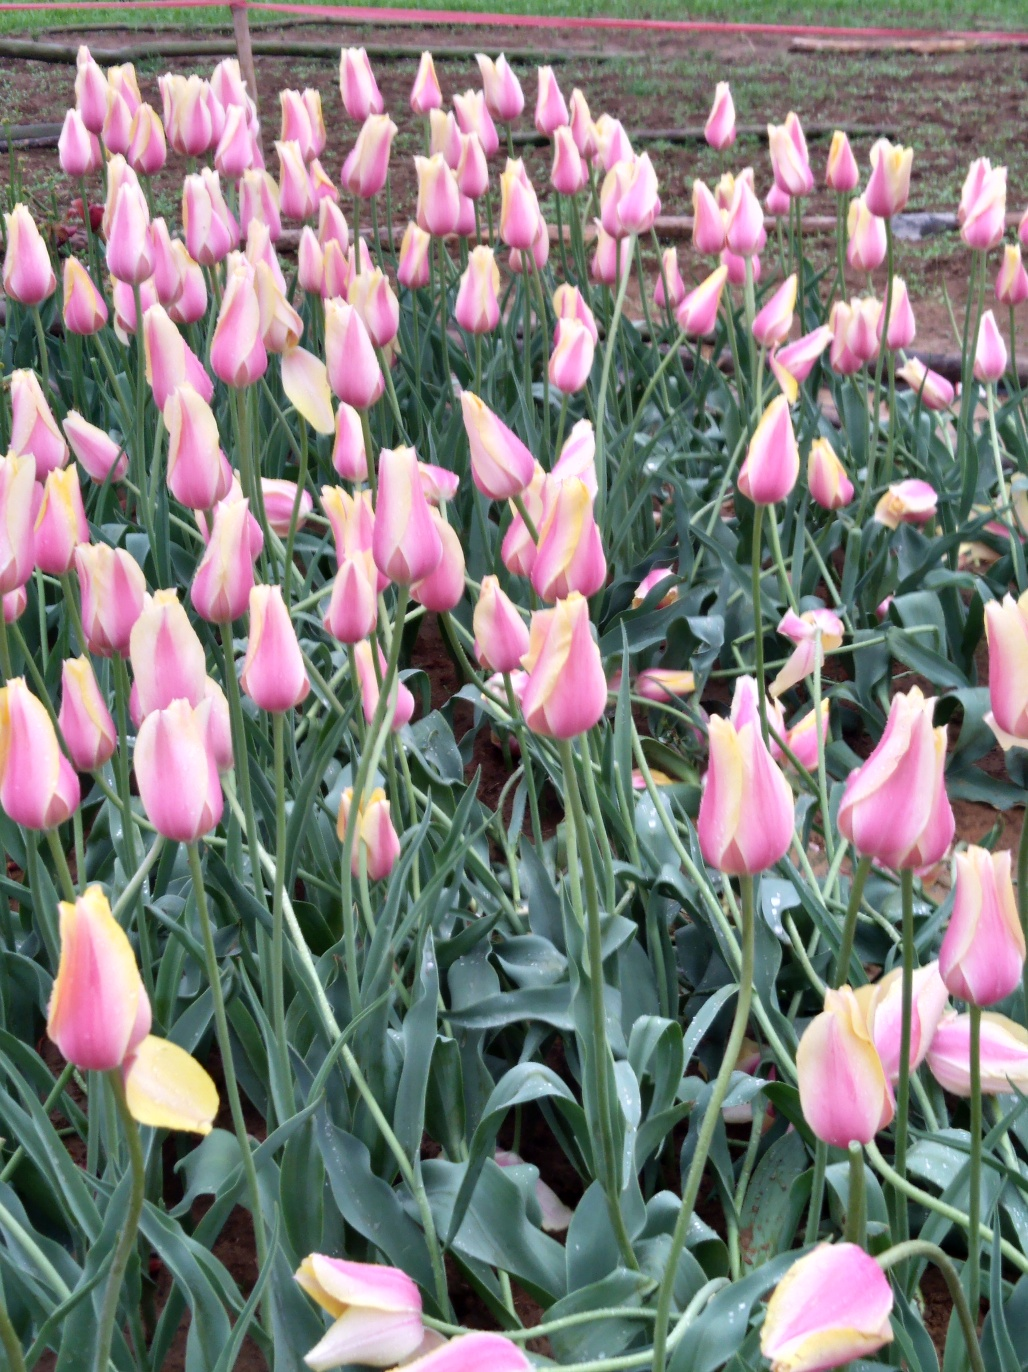What is the image quality? The image quality is quite decent with good focus on the foreground tulips, though there is a slight blurring towards the background which suggests a shallow depth of field was used. The colors are vibrant, capturing the pink and yellow hues of the tulips nicely against the green of the leaves. 